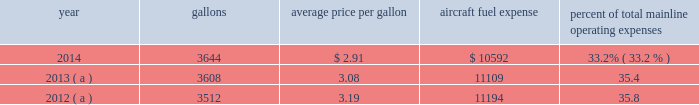Table of contents respect to the mainline american and the mainline us airways dispatchers , flight simulator engineers and flight crew training instructors , all of whom are now represented by the twu , a rival organization , the national association of airline professionals ( naap ) , filed single carrier applications seeking to represent those employees .
The nmb will have to determine that a single transportation system exists and will certify a post-merger representative of the combined employee groups before the process for negotiating new jcbas can begin .
The merger had no impact on the cbas that cover the employees of our wholly-owned subsidiary airlines which are not being merged ( envoy , piedmont and psa ) .
For those employees , the rla provides that cbas do not expire , but instead become amendable as of a stated date .
In 2014 , envoy pilots ratified a new 10 year collective bargaining agreement , piedmont pilots ratified a new 10 year collective bargaining agreement and piedmont flight attendants ratified a new five-year collective bargaining agreement .
With the exception of the passenger service employees who are now engaged in traditional rla negotiations that are expected to result in a jcba and the us airways flight simulator engineers and flight crew training instructors , other union-represented american mainline employees are covered by agreements that are not currently amendable .
Until those agreements become amendable , negotiations for jcbas will be conducted outside the traditional rla bargaining process described above , and , in the meantime , no self-help will be permissible .
The piedmont mechanics and stock clerks and the psa and piedmont dispatchers also have agreements that are now amendable and are engaged in traditional rla negotiations .
None of the unions representing our employees presently may lawfully engage in concerted refusals to work , such as strikes , slow-downs , sick-outs or other similar activity , against us .
Nonetheless , there is a risk that disgruntled employees , either with or without union involvement , could engage in one or more concerted refusals to work that could individually or collectively harm the operation of our airline and impair our financial performance .
For more discussion , see part i , item 1a .
Risk factors 2013 201cunion disputes , employee strikes and other labor-related disruptions may adversely affect our operations . 201d aircraft fuel our operations and financial results are significantly affected by the availability and price of jet fuel .
Based on our 2015 forecasted mainline and regional fuel consumption , we estimate that , as of december 31 , 2014 , a one cent per gallon increase in aviation fuel price would increase our 2015 annual fuel expense by $ 43 million .
The table shows annual aircraft fuel consumption and costs , including taxes , for our mainline operations for 2012 through 2014 ( gallons and aircraft fuel expense in millions ) .
Year gallons average price per gallon aircraft fuel expense percent of total mainline operating expenses .
( a ) represents 201ccombined 201d financial data , which includes the financial results of american and us airways group each on a standalone basis .
Total combined fuel expenses for our wholly-owned and third-party regional carriers operating under capacity purchase agreements of american and us airways group , each on a standalone basis , were $ 2.0 billion , $ 2.1 billion and $ 2.1 billion for the years ended december 31 , 2014 , 2013 and 2012 , respectively. .
In 2014 what was the total mainline operating expenses in millions? 
Rationale: the total operating expenses is derived as a result of dividing the fuel expenses by their percent of operating costs
Computations: (10592 / 33.2%)
Answer: 31903.61446. 